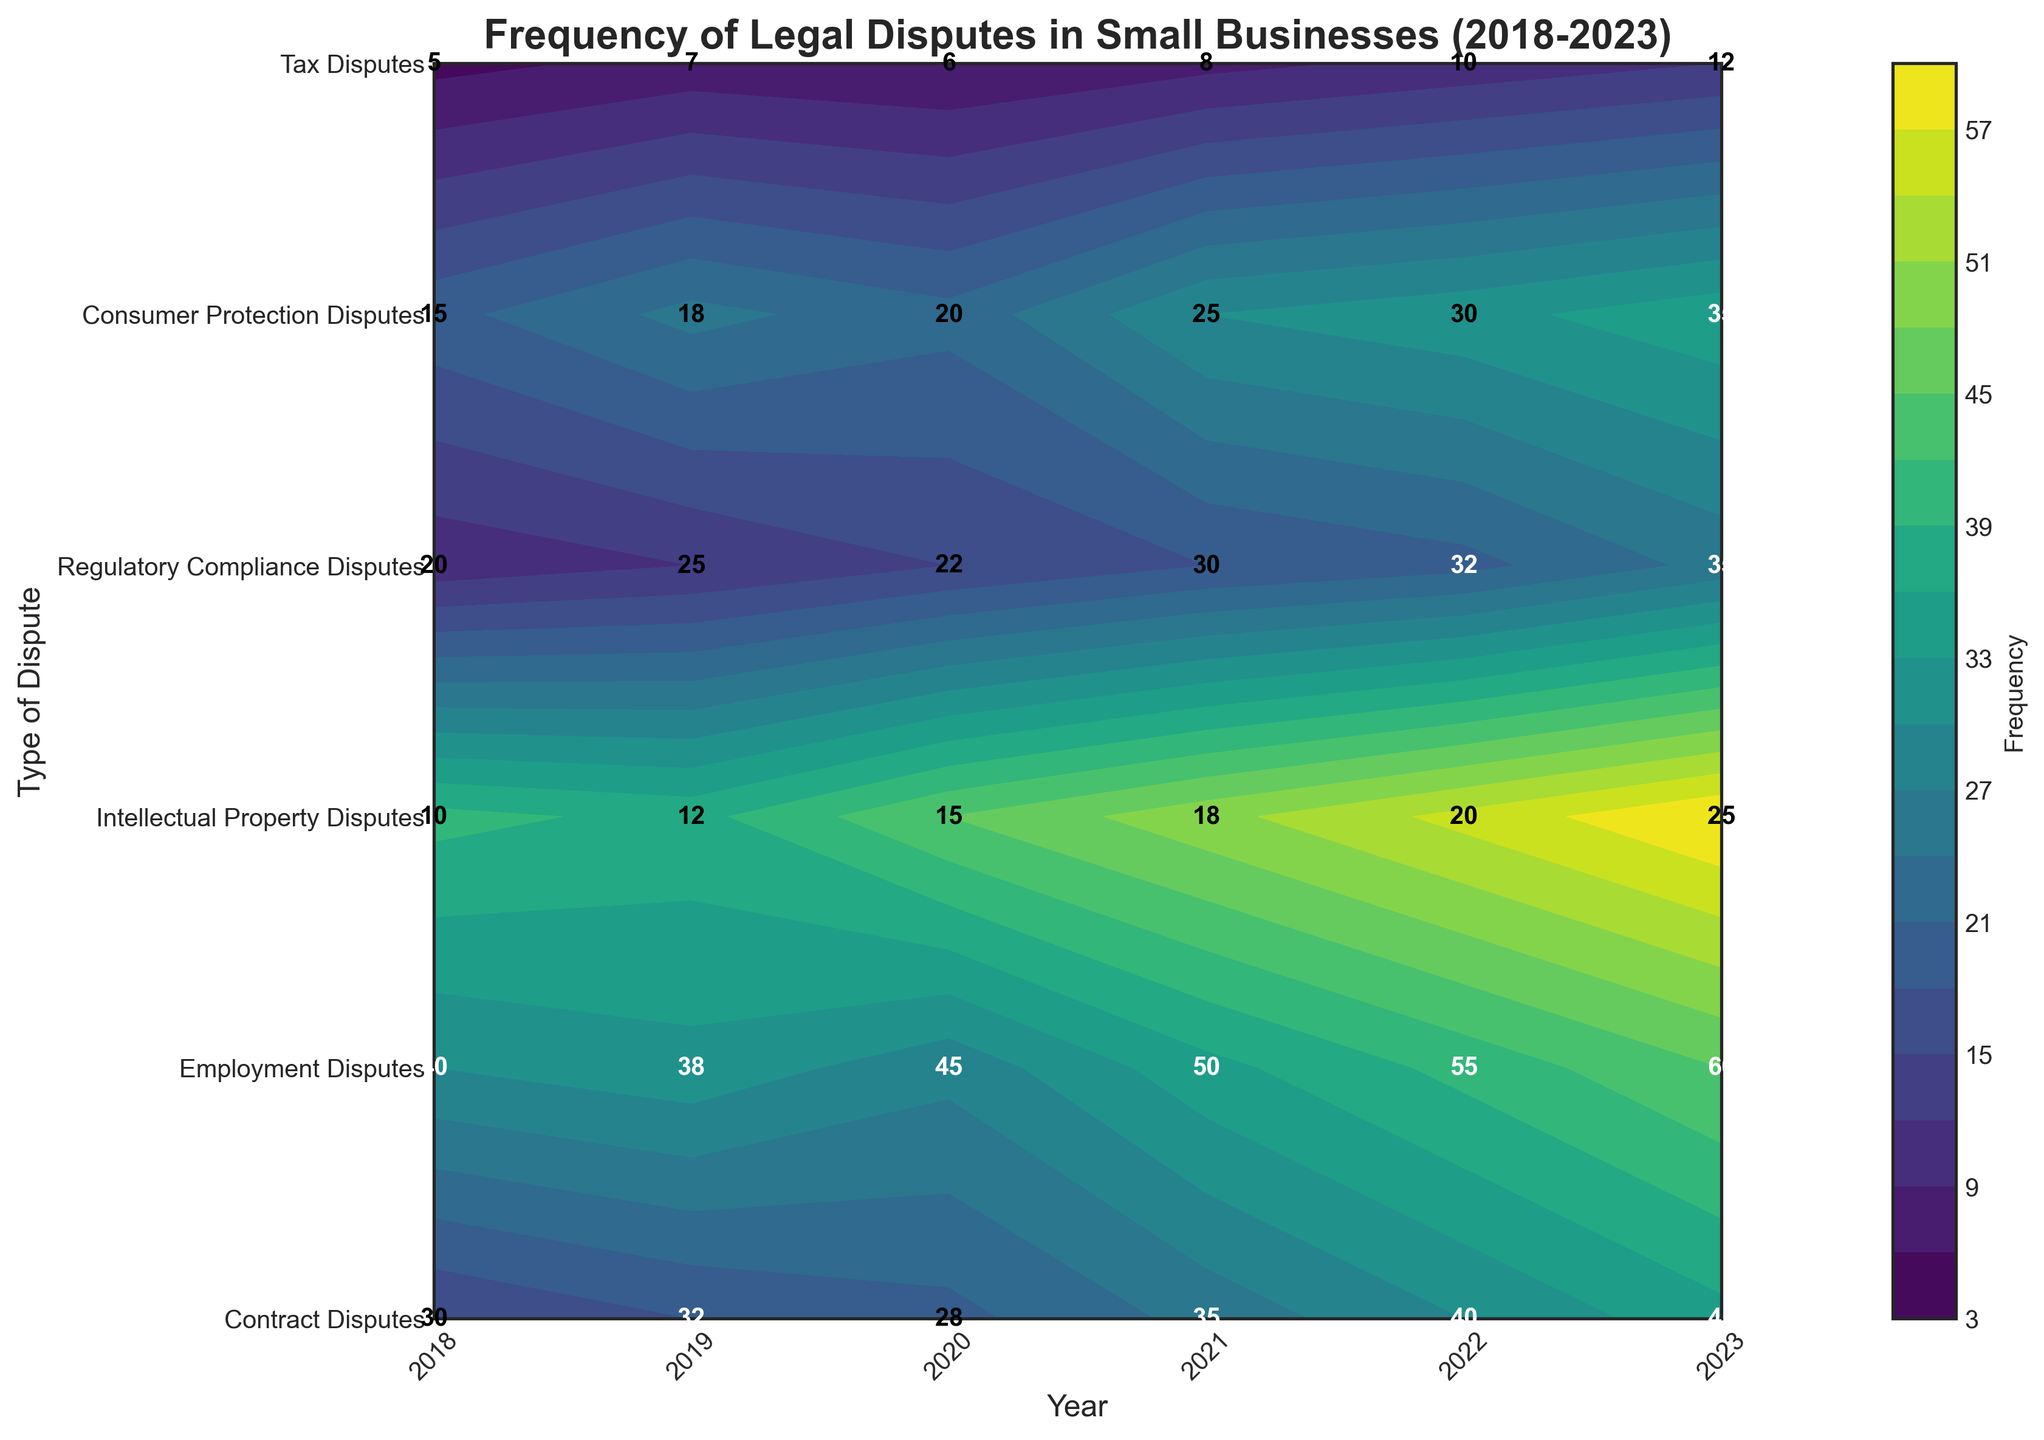What is the most frequent type of legal dispute in 2023? The contour plot shows the frequency of each dispute type over the years. For 2023, the contour levels help identify that Employment Disputes have the highest frequency.
Answer: Employment Disputes How has the frequency of Employment Disputes changed from 2018 to 2023? By observing the contour plot, you can see a steady increase in the frequency of Employment Disputes from 40 in 2018 to 60 in 2023.
Answer: Increased by 20 Which type of dispute had the least frequency in 2018, and what was its value? In 2018, the lowest frequency is depicted by the lowest contour level in the plot, which corresponds to Tax Disputes with a frequency of 5.
Answer: Tax Disputes, 5 Between which years did Regulatory Compliance Disputes see the most significant increase in frequency? Observing the contour levels over the years for Regulatory Compliance Disputes, the most significant jump happens between 2020 and 2021, from 22 to 30.
Answer: 2020 to 2021 Which type of dispute showed consistent growth every year from 2018 to 2023? By scanning the contour plot year by year, Employment Disputes consistently increase every year from 2018 to 2023.
Answer: Employment Disputes What is the average frequency of Contract Disputes between 2018 and 2023? To find the average, sum the frequencies of Contract Disputes from each year (30 + 32 + 28 + 35 + 40 + 45) and divide by the number of years (6). The sum is 210, and the average is 210 / 6 = 35.
Answer: 35 How do Consumer Protection Disputes in 2022 compare with those in 2018? By comparing the contour levels for Consumer Protection Disputes between these years, the frequency increased from 15 in 2018 to 30 in 2022.
Answer: Increased by 15 What trend can be observed for Intellectual Property Disputes from 2018 to 2023? The contour plot shows an overall increase in frequency, from 10 in 2018 to 25 in 2023, indicating a rising trend.
Answer: Increasing trend Which year had the highest total frequency of all disputes combined? By summing the frequencies across all dispute types for each year and comparing, 2023 has the highest total with a sum of all frequencies amounting to 212.
Answer: 2023 